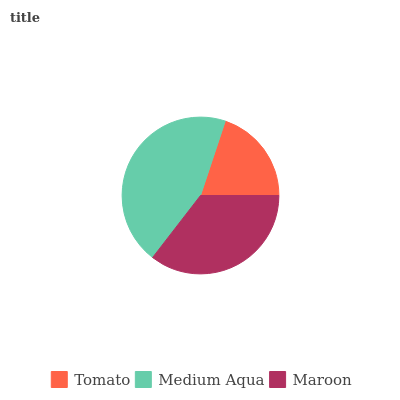Is Tomato the minimum?
Answer yes or no. Yes. Is Medium Aqua the maximum?
Answer yes or no. Yes. Is Maroon the minimum?
Answer yes or no. No. Is Maroon the maximum?
Answer yes or no. No. Is Medium Aqua greater than Maroon?
Answer yes or no. Yes. Is Maroon less than Medium Aqua?
Answer yes or no. Yes. Is Maroon greater than Medium Aqua?
Answer yes or no. No. Is Medium Aqua less than Maroon?
Answer yes or no. No. Is Maroon the high median?
Answer yes or no. Yes. Is Maroon the low median?
Answer yes or no. Yes. Is Tomato the high median?
Answer yes or no. No. Is Tomato the low median?
Answer yes or no. No. 